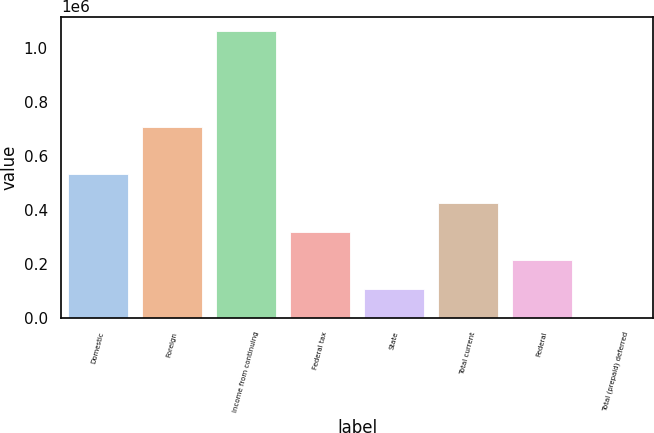<chart> <loc_0><loc_0><loc_500><loc_500><bar_chart><fcel>Domestic<fcel>Foreign<fcel>Income from continuing<fcel>Federal tax<fcel>State<fcel>Total current<fcel>Federal<fcel>Total (prepaid) deferred<nl><fcel>531576<fcel>705628<fcel>1.06145e+06<fcel>319627<fcel>107678<fcel>425601<fcel>213653<fcel>1704<nl></chart> 